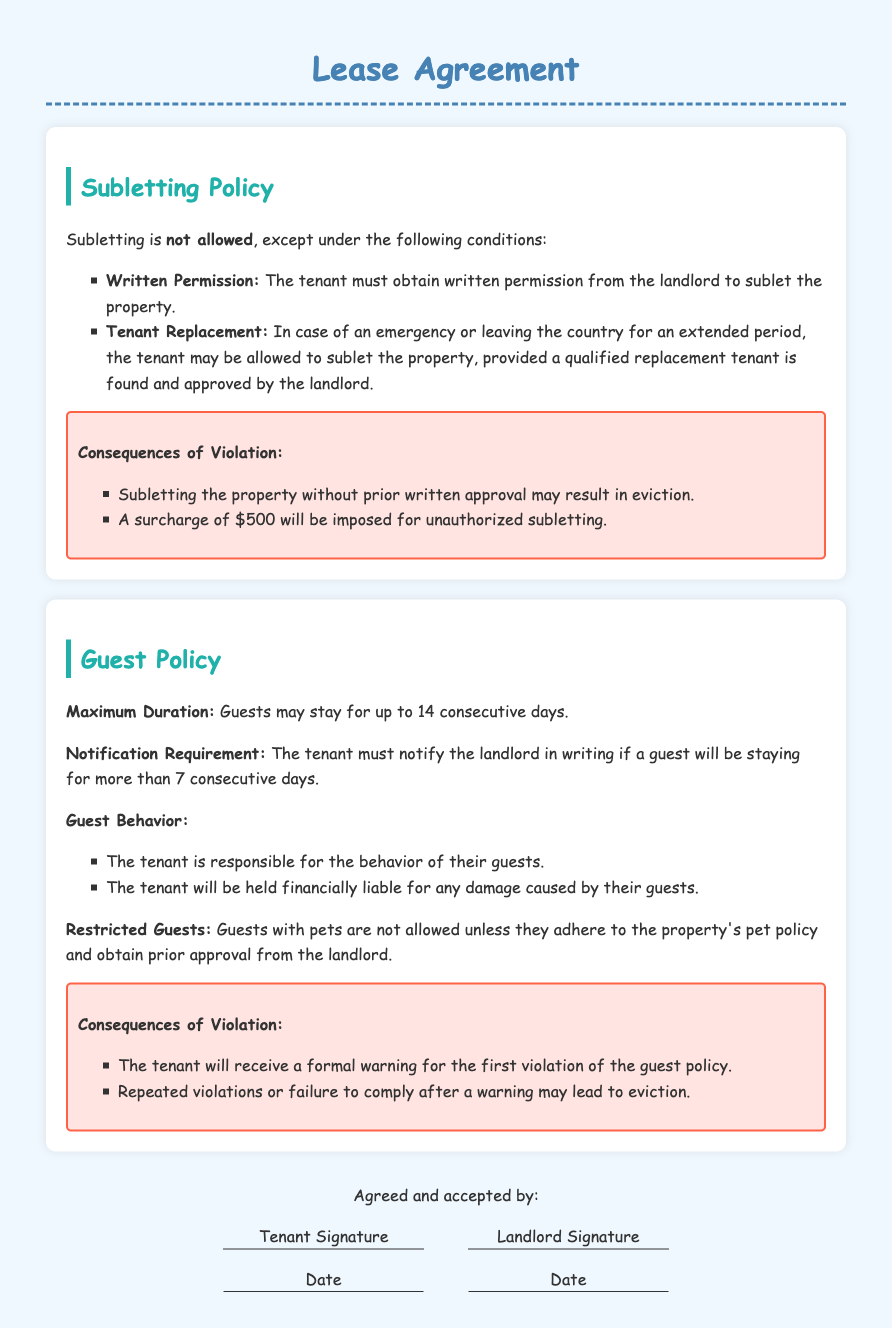What is required for subletting? Subletting requires written permission from the landlord and a qualified replacement tenant may be considered in emergencies.
Answer: Written permission What is the maximum duration a guest can stay? The maximum duration for a guest's stay is clearly defined in the guest policy section.
Answer: 14 consecutive days What happens if someone sublets without approval? The document explicitly states the consequences of unauthorized subletting, including specific penalties involved.
Answer: Eviction and $500 surcharge How long must the tenant notify the landlord about guests? The tenant is required to provide notification to the landlord in writing when a guest stays beyond a certain specified period.
Answer: More than 7 consecutive days Who is financially liable for guest-caused damages? The document points out the responsibilities of the tenant regarding their guests and any damages caused.
Answer: Tenant What kind of guests are restricted? There is a specific mention of restrictions for certain guests based on their pet ownership status in the guest policy section.
Answer: Guests with pets What happens after the first violation of the guest policy? The document describes the consequences for a first violation, indicating the landlord's response to non-compliance.
Answer: Formal warning What must the tenant do in case of an emergency regarding subletting? The emergency protocol for the tenant is outlined, focusing on the requirement for landlord approval and tenant qualification.
Answer: Find a qualified replacement tenant What are the consequences of repeated violations of the guest policy? The lease agreement specifies the escalation of consequences based on the number of violations related to guest policies.
Answer: Eviction 